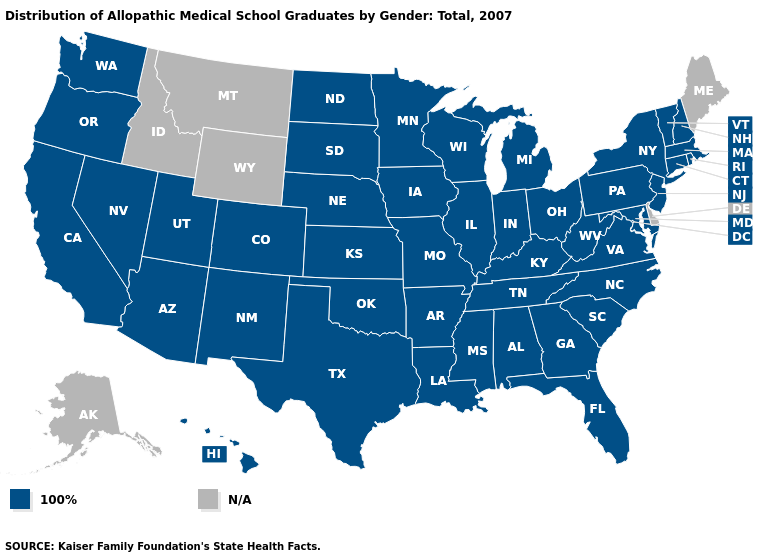Name the states that have a value in the range 100%?
Answer briefly. Alabama, Arizona, Arkansas, California, Colorado, Connecticut, Florida, Georgia, Hawaii, Illinois, Indiana, Iowa, Kansas, Kentucky, Louisiana, Maryland, Massachusetts, Michigan, Minnesota, Mississippi, Missouri, Nebraska, Nevada, New Hampshire, New Jersey, New Mexico, New York, North Carolina, North Dakota, Ohio, Oklahoma, Oregon, Pennsylvania, Rhode Island, South Carolina, South Dakota, Tennessee, Texas, Utah, Vermont, Virginia, Washington, West Virginia, Wisconsin. Name the states that have a value in the range 100%?
Be succinct. Alabama, Arizona, Arkansas, California, Colorado, Connecticut, Florida, Georgia, Hawaii, Illinois, Indiana, Iowa, Kansas, Kentucky, Louisiana, Maryland, Massachusetts, Michigan, Minnesota, Mississippi, Missouri, Nebraska, Nevada, New Hampshire, New Jersey, New Mexico, New York, North Carolina, North Dakota, Ohio, Oklahoma, Oregon, Pennsylvania, Rhode Island, South Carolina, South Dakota, Tennessee, Texas, Utah, Vermont, Virginia, Washington, West Virginia, Wisconsin. Does the first symbol in the legend represent the smallest category?
Write a very short answer. Yes. Which states have the lowest value in the South?
Keep it brief. Alabama, Arkansas, Florida, Georgia, Kentucky, Louisiana, Maryland, Mississippi, North Carolina, Oklahoma, South Carolina, Tennessee, Texas, Virginia, West Virginia. What is the value of Texas?
Answer briefly. 100%. Among the states that border Georgia , which have the lowest value?
Write a very short answer. Alabama, Florida, North Carolina, South Carolina, Tennessee. What is the value of Iowa?
Keep it brief. 100%. Which states have the highest value in the USA?
Keep it brief. Alabama, Arizona, Arkansas, California, Colorado, Connecticut, Florida, Georgia, Hawaii, Illinois, Indiana, Iowa, Kansas, Kentucky, Louisiana, Maryland, Massachusetts, Michigan, Minnesota, Mississippi, Missouri, Nebraska, Nevada, New Hampshire, New Jersey, New Mexico, New York, North Carolina, North Dakota, Ohio, Oklahoma, Oregon, Pennsylvania, Rhode Island, South Carolina, South Dakota, Tennessee, Texas, Utah, Vermont, Virginia, Washington, West Virginia, Wisconsin. Among the states that border Iowa , which have the lowest value?
Short answer required. Illinois, Minnesota, Missouri, Nebraska, South Dakota, Wisconsin. Among the states that border Massachusetts , which have the highest value?
Give a very brief answer. Connecticut, New Hampshire, New York, Rhode Island, Vermont. Among the states that border Oklahoma , which have the highest value?
Answer briefly. Arkansas, Colorado, Kansas, Missouri, New Mexico, Texas. What is the value of Rhode Island?
Concise answer only. 100%. 